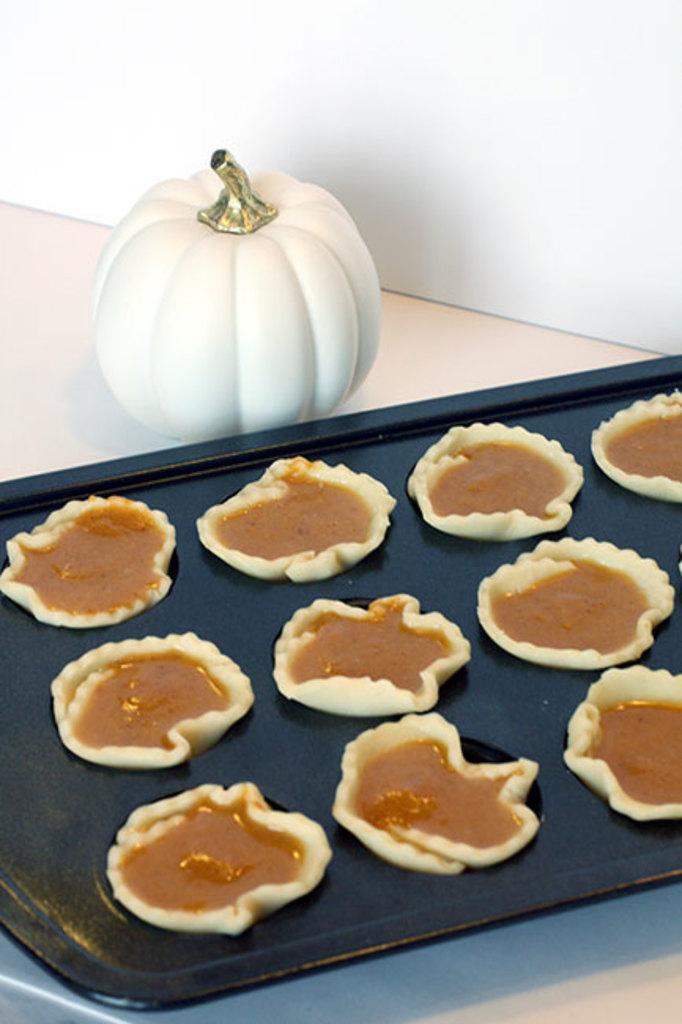Please provide a concise description of this image. In this image there is a table, on that table there is a plate in that place there are food items. 